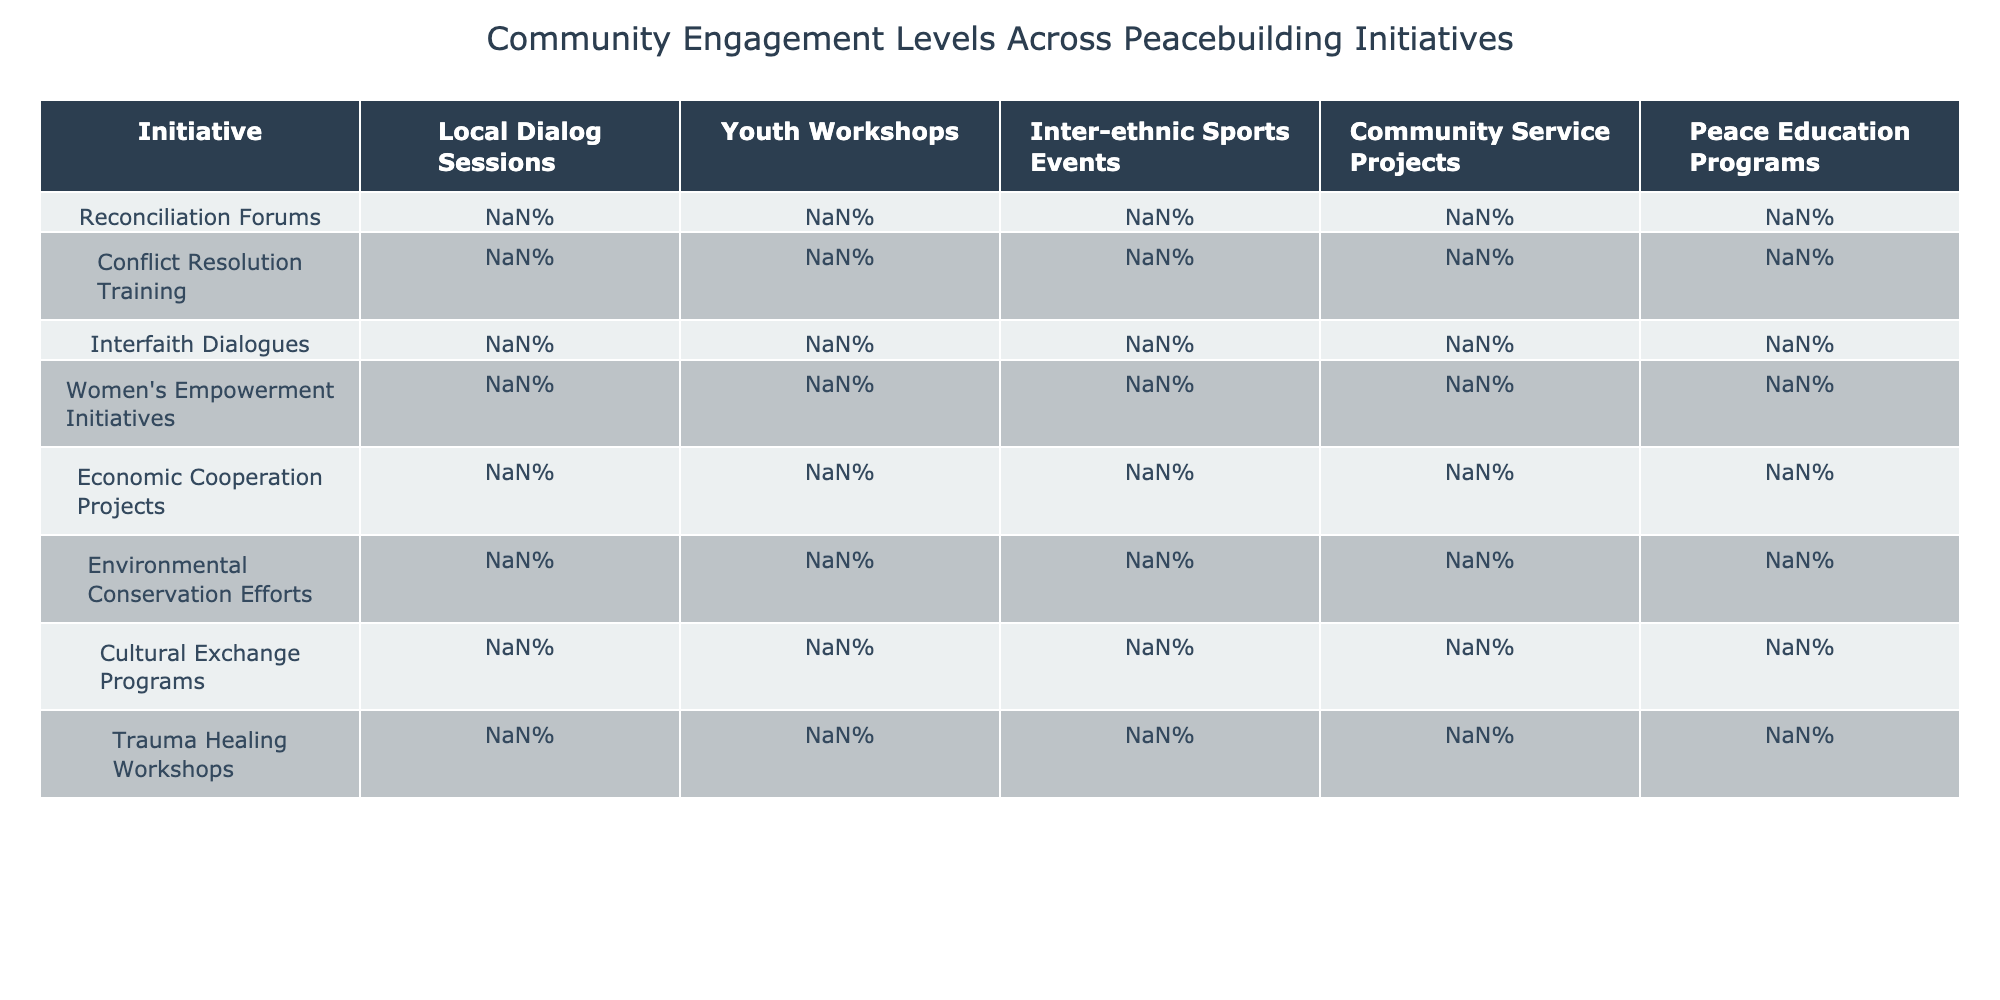What is the highest engagement percentage in Local Dialog Sessions? The highest percentage in Local Dialog Sessions can be found by scanning the values. The maximum value is 91% from the Trauma Healing Workshops.
Answer: 91% Which initiative has the lowest engagement in Youth Workshops? To find the lowest value in Youth Workshops, we compare all the percentages. The minimum value is 65%, which belongs to the Interfaith Dialogues.
Answer: 65% What is the average engagement percentage across all initiatives for Community Service Projects? To calculate the average, sum all the percentages for Community Service Projects: (79% + 75% + 71% + 88% + 92% + 95% + 73% + 68%)/8 = 79.875%, which rounds to 80%.
Answer: 80% Is the engagement in Peace Education Programs consistently higher than 75% across all initiatives? By reviewing each percentage for Peace Education Programs, we find the values: 81%, 93%, 88%, 79%, 70%, 68%, 86%, 90%. The last two initiatives (Economic Cooperation Projects and Environmental Conservation Efforts) fall below 75%, so the statement is false.
Answer: No Which initiative shows the greatest difference between the highest and lowest engagement percentages? To find the largest difference, we determine the maximum and minimum engagement percentages for each initiative. The Reconciliation Forums have a high of 85% and a low of 68%, resulting in a difference of 17%. The Economic Cooperation Projects have a high of 92% and a low of 69%, resulting in a difference of 23%. Thus, Economic Cooperation Projects have the greatest difference.
Answer: Economic Cooperation Projects How does the engagement in Conflict Resolution Training compare to Interfaith Dialogues in Sports Events? The engagement percentage for Conflict Resolution Training in Inter-ethnic Sports Events is 62%, while for Interfaith Dialogues it is 57%. Comparing both, Conflict Resolution Training has a higher engagement by 5%.
Answer: Higher by 5% Which group has greater engagement in Environmental Conservation Efforts than in Women's Empowerment Initiatives? For Environmental Conservation Efforts, the engagement percentages are 72%, 81%, 76%, 95%, 68%, while for Women's Empowerment Initiatives, the engagements are 76%, 84%, 71%, 88%, 79%. By comparing each percentage, we find that only for the initiative "Community Service Projects" Environmental Conservation Efforts (95%) exceeded Women's Empowerment Initiatives (88%).
Answer: One initiative (Community Service Projects) Which initiative with the lowest engagement in Youth Workshops still performed above 70% in Peace Education Programs? The lowest engagement in Youth Workshops is 65% from Interfaith Dialogues, but its engagement in Peace Education Programs is 88%, which is above 70%.
Answer: Yes What is the median engagement level across all initiatives for Local Dialog Sessions? To find the median, we first sort the engagement percentages for Local Dialog Sessions: 69%, 76%, 78%, 82%, 85%, 88%, 91%. The median is the middle value; since there are 8 values, we average the 4th and 5th (82% + 85%) = 83.5%.
Answer: 83.5% 